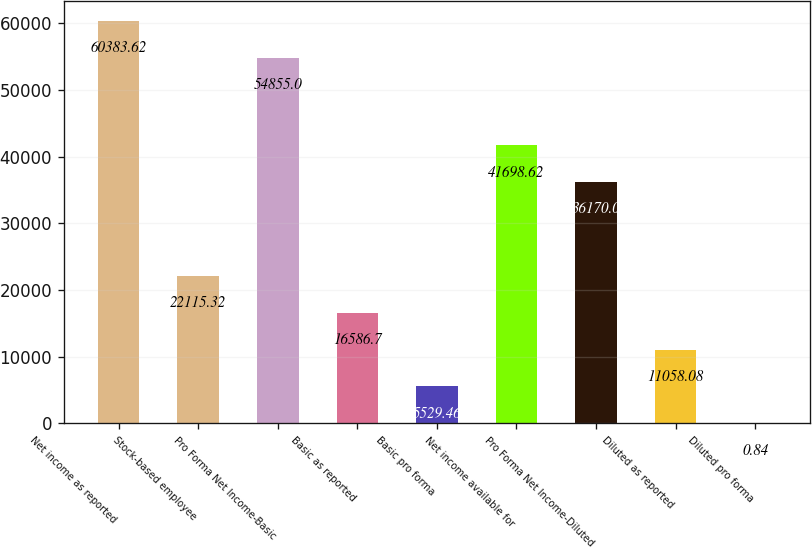Convert chart to OTSL. <chart><loc_0><loc_0><loc_500><loc_500><bar_chart><fcel>Net income as reported<fcel>Stock-based employee<fcel>Pro Forma Net Income-Basic<fcel>Basic as reported<fcel>Basic pro forma<fcel>Net income available for<fcel>Pro Forma Net Income-Diluted<fcel>Diluted as reported<fcel>Diluted pro forma<nl><fcel>60383.6<fcel>22115.3<fcel>54855<fcel>16586.7<fcel>5529.46<fcel>41698.6<fcel>36170<fcel>11058.1<fcel>0.84<nl></chart> 